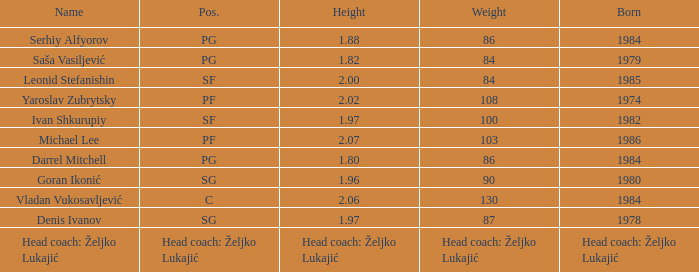80m? PG. 